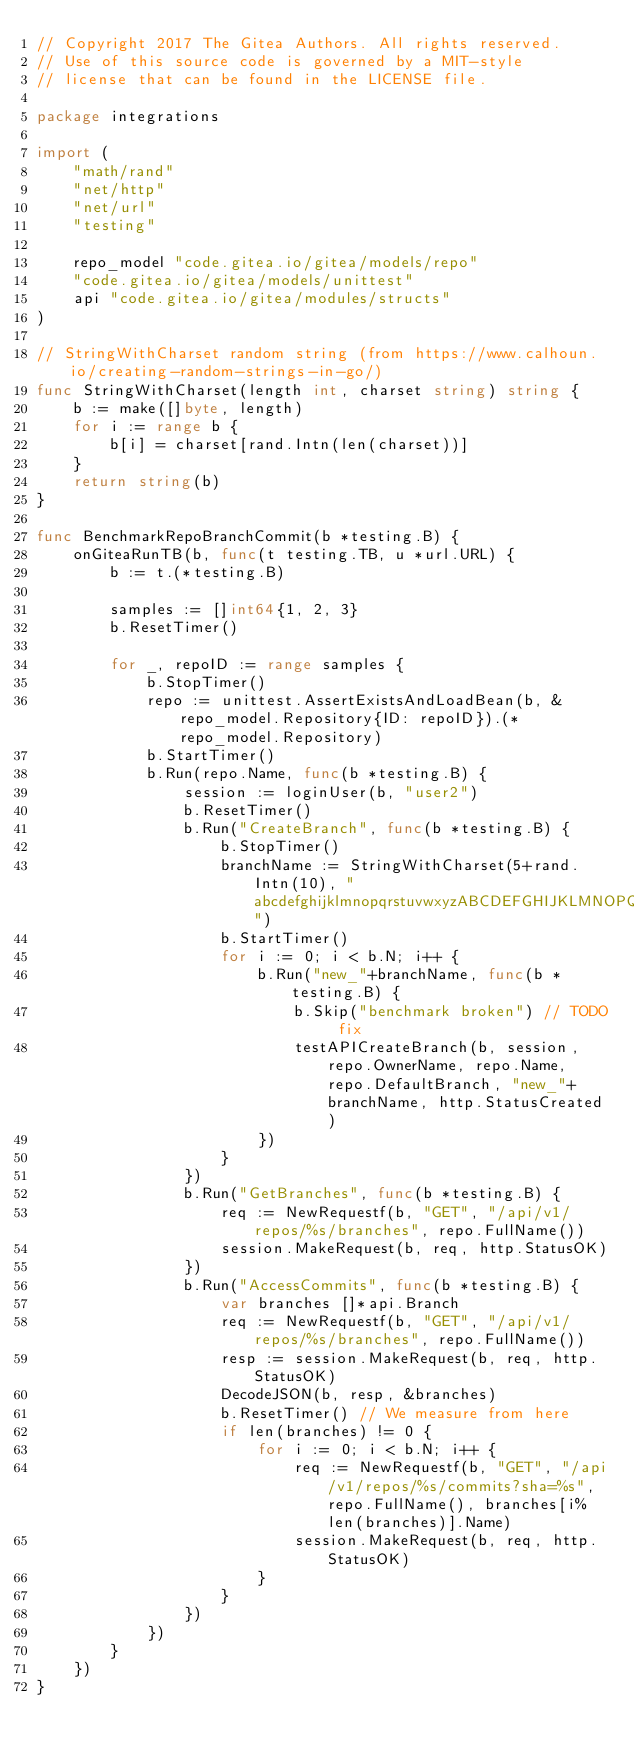Convert code to text. <code><loc_0><loc_0><loc_500><loc_500><_Go_>// Copyright 2017 The Gitea Authors. All rights reserved.
// Use of this source code is governed by a MIT-style
// license that can be found in the LICENSE file.

package integrations

import (
	"math/rand"
	"net/http"
	"net/url"
	"testing"

	repo_model "code.gitea.io/gitea/models/repo"
	"code.gitea.io/gitea/models/unittest"
	api "code.gitea.io/gitea/modules/structs"
)

// StringWithCharset random string (from https://www.calhoun.io/creating-random-strings-in-go/)
func StringWithCharset(length int, charset string) string {
	b := make([]byte, length)
	for i := range b {
		b[i] = charset[rand.Intn(len(charset))]
	}
	return string(b)
}

func BenchmarkRepoBranchCommit(b *testing.B) {
	onGiteaRunTB(b, func(t testing.TB, u *url.URL) {
		b := t.(*testing.B)

		samples := []int64{1, 2, 3}
		b.ResetTimer()

		for _, repoID := range samples {
			b.StopTimer()
			repo := unittest.AssertExistsAndLoadBean(b, &repo_model.Repository{ID: repoID}).(*repo_model.Repository)
			b.StartTimer()
			b.Run(repo.Name, func(b *testing.B) {
				session := loginUser(b, "user2")
				b.ResetTimer()
				b.Run("CreateBranch", func(b *testing.B) {
					b.StopTimer()
					branchName := StringWithCharset(5+rand.Intn(10), "abcdefghijklmnopqrstuvwxyzABCDEFGHIJKLMNOPQRSTUVWXYZ0123456789")
					b.StartTimer()
					for i := 0; i < b.N; i++ {
						b.Run("new_"+branchName, func(b *testing.B) {
							b.Skip("benchmark broken") // TODO fix
							testAPICreateBranch(b, session, repo.OwnerName, repo.Name, repo.DefaultBranch, "new_"+branchName, http.StatusCreated)
						})
					}
				})
				b.Run("GetBranches", func(b *testing.B) {
					req := NewRequestf(b, "GET", "/api/v1/repos/%s/branches", repo.FullName())
					session.MakeRequest(b, req, http.StatusOK)
				})
				b.Run("AccessCommits", func(b *testing.B) {
					var branches []*api.Branch
					req := NewRequestf(b, "GET", "/api/v1/repos/%s/branches", repo.FullName())
					resp := session.MakeRequest(b, req, http.StatusOK)
					DecodeJSON(b, resp, &branches)
					b.ResetTimer() // We measure from here
					if len(branches) != 0 {
						for i := 0; i < b.N; i++ {
							req := NewRequestf(b, "GET", "/api/v1/repos/%s/commits?sha=%s", repo.FullName(), branches[i%len(branches)].Name)
							session.MakeRequest(b, req, http.StatusOK)
						}
					}
				})
			})
		}
	})
}
</code> 